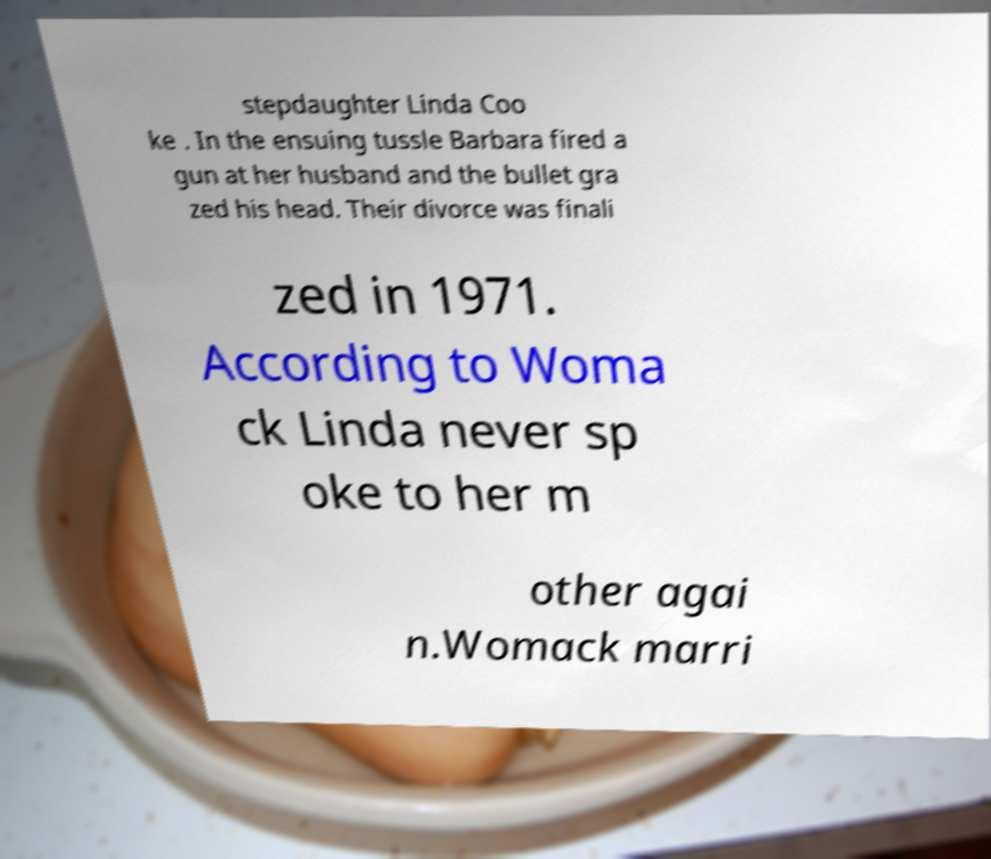Can you accurately transcribe the text from the provided image for me? stepdaughter Linda Coo ke . In the ensuing tussle Barbara fired a gun at her husband and the bullet gra zed his head. Their divorce was finali zed in 1971. According to Woma ck Linda never sp oke to her m other agai n.Womack marri 